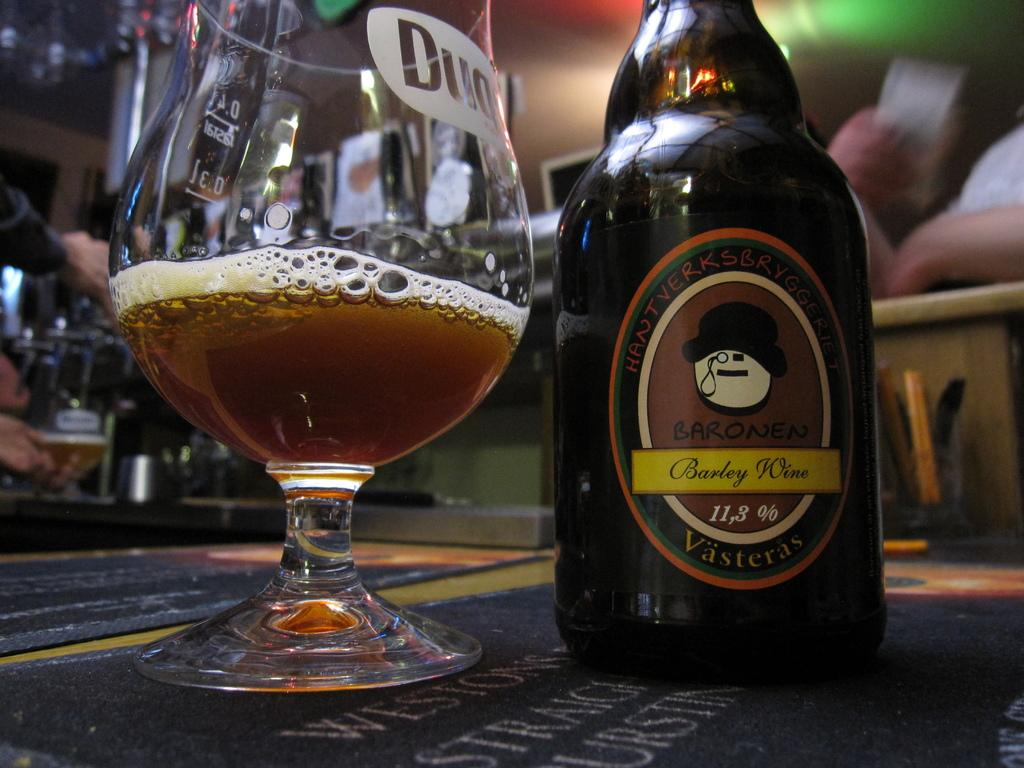<image>
Summarize the visual content of the image. A half full glass sits next to a bottle of barley wine. 